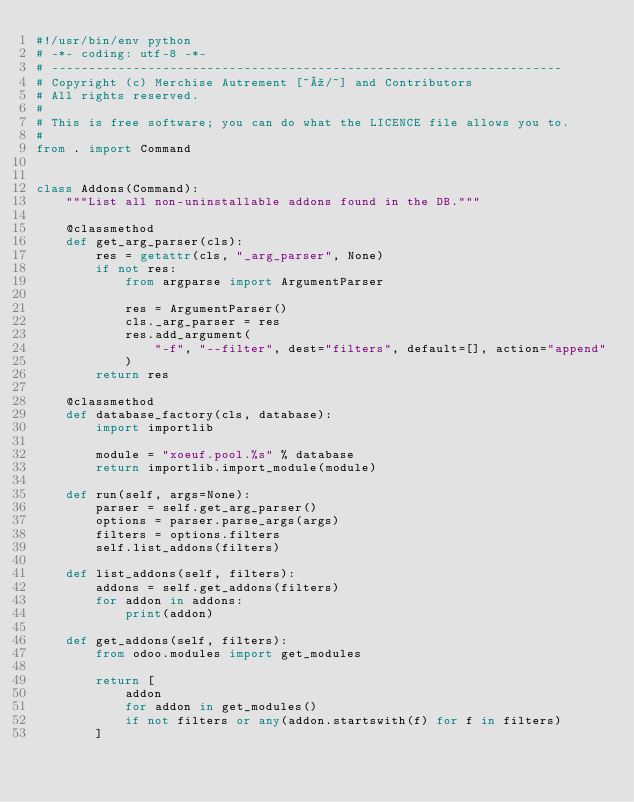Convert code to text. <code><loc_0><loc_0><loc_500><loc_500><_Python_>#!/usr/bin/env python
# -*- coding: utf-8 -*-
# ---------------------------------------------------------------------
# Copyright (c) Merchise Autrement [~º/~] and Contributors
# All rights reserved.
#
# This is free software; you can do what the LICENCE file allows you to.
#
from . import Command


class Addons(Command):
    """List all non-uninstallable addons found in the DB."""

    @classmethod
    def get_arg_parser(cls):
        res = getattr(cls, "_arg_parser", None)
        if not res:
            from argparse import ArgumentParser

            res = ArgumentParser()
            cls._arg_parser = res
            res.add_argument(
                "-f", "--filter", dest="filters", default=[], action="append"
            )
        return res

    @classmethod
    def database_factory(cls, database):
        import importlib

        module = "xoeuf.pool.%s" % database
        return importlib.import_module(module)

    def run(self, args=None):
        parser = self.get_arg_parser()
        options = parser.parse_args(args)
        filters = options.filters
        self.list_addons(filters)

    def list_addons(self, filters):
        addons = self.get_addons(filters)
        for addon in addons:
            print(addon)

    def get_addons(self, filters):
        from odoo.modules import get_modules

        return [
            addon
            for addon in get_modules()
            if not filters or any(addon.startswith(f) for f in filters)
        ]
</code> 